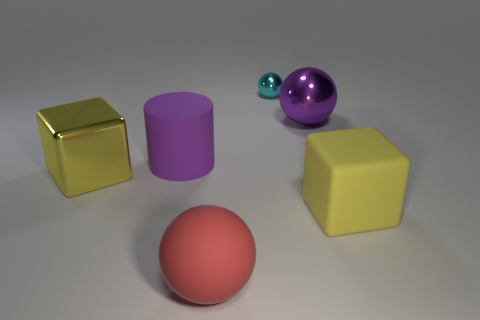Subtract all big balls. How many balls are left? 1 Add 4 large red objects. How many objects exist? 10 Subtract all red balls. How many balls are left? 2 Subtract all cylinders. How many objects are left? 5 Subtract 2 balls. How many balls are left? 1 Subtract all blue balls. Subtract all purple cylinders. How many balls are left? 3 Subtract all blue cubes. How many green spheres are left? 0 Subtract all large yellow metallic objects. Subtract all blue rubber cubes. How many objects are left? 5 Add 3 tiny cyan metal things. How many tiny cyan metal things are left? 4 Add 6 tiny cyan balls. How many tiny cyan balls exist? 7 